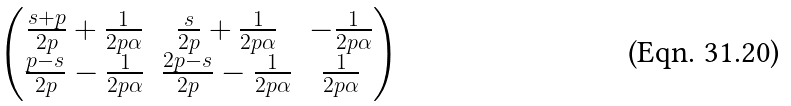<formula> <loc_0><loc_0><loc_500><loc_500>\begin{pmatrix} \frac { s + p } { 2 p } + \frac { 1 } { 2 p \alpha } & \frac { s } { 2 p } + \frac { 1 } { 2 p \alpha } & - \frac { 1 } { 2 p \alpha } \\ \frac { p - s } { 2 p } - \frac { 1 } { 2 p \alpha } & \frac { 2 p - s } { 2 p } - \frac { 1 } { 2 p \alpha } & \frac { 1 } { 2 p \alpha } \end{pmatrix}</formula> 